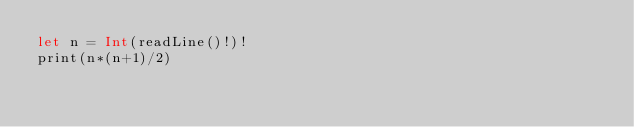Convert code to text. <code><loc_0><loc_0><loc_500><loc_500><_Swift_>let n = Int(readLine()!)!
print(n*(n+1)/2)</code> 